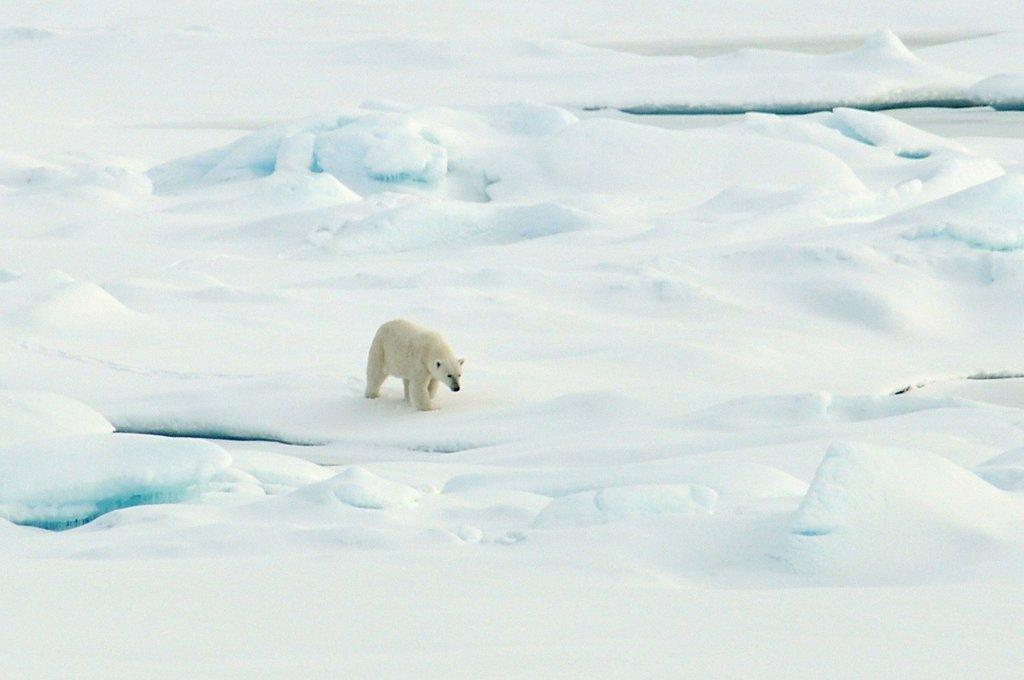What type of animal is in the image? There is a white polar bear in the image. Where is the polar bear located? The polar bear is on the ice. What type of office furniture can be seen in the image? There is no office furniture present in the image, as it features a polar bear on the ice. How does the polar bear show respect to the other animals in the image? There are no other animals present in the image, so it is not possible to determine how the polar bear might show respect. 